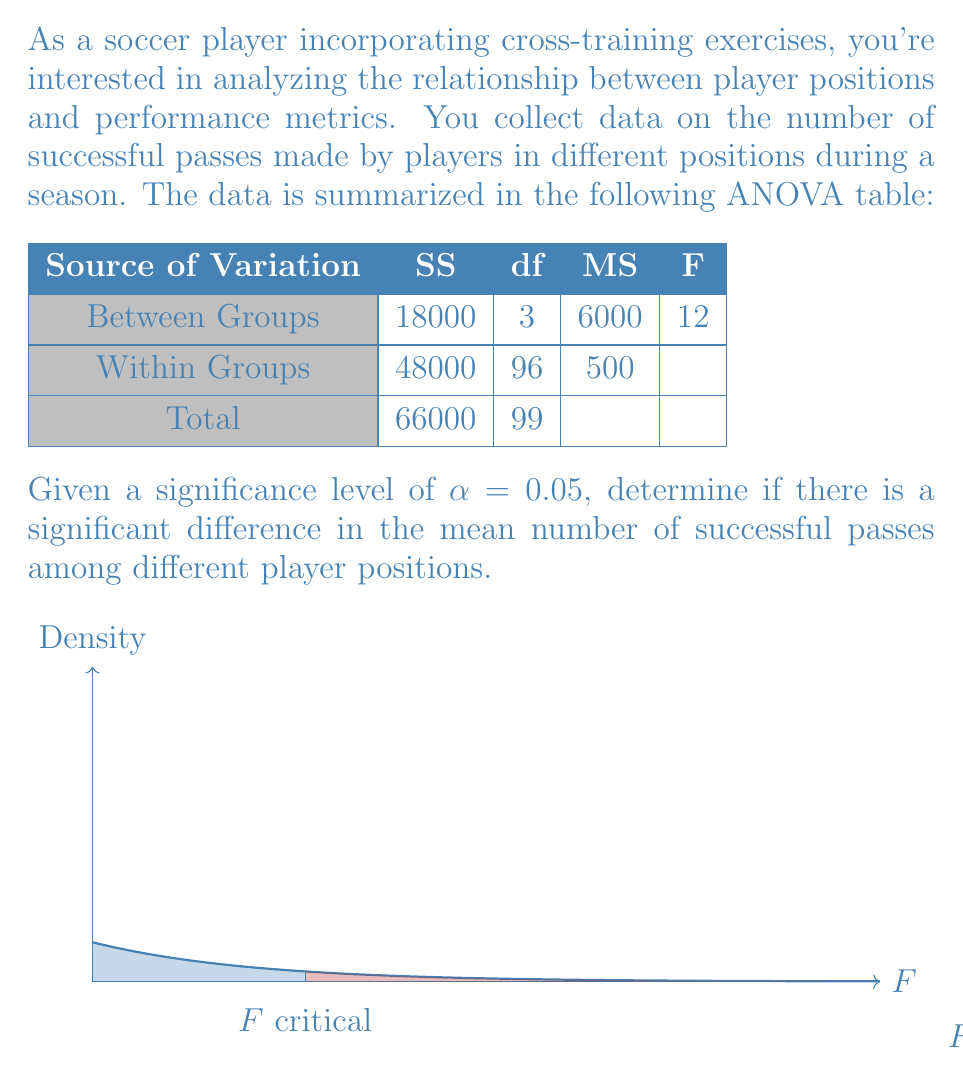Help me with this question. To determine if there's a significant difference in the mean number of successful passes among different player positions, we'll follow these steps:

1) First, we need to identify our null and alternative hypotheses:
   $H_0$: There is no significant difference in mean successful passes among positions.
   $H_a$: There is a significant difference in mean successful passes among positions.

2) We're given α = 0.05 as our significance level.

3) From the ANOVA table, we can see that:
   - F calculated = 12
   - df between groups (numerator) = 3
   - df within groups (denominator) = 96

4) We need to find the critical F-value. Using an F-distribution table or calculator with df1 = 3 and df2 = 96 at α = 0.05:
   F critical ≈ 2.699

5) Decision rule: Reject $H_0$ if F calculated > F critical

6) Compare:
   F calculated (12) > F critical (2.699)

7) The p-value for this test would be very small (p < 0.001), which is less than α = 0.05.

8) Interpret the results: Since F calculated is greater than F critical, we reject the null hypothesis.

The diagram shows the F-distribution, with the calculated F-value clearly in the rejection region.
Answer: Reject $H_0$; significant difference in mean successful passes among positions (F(3,96) = 12, p < 0.05). 